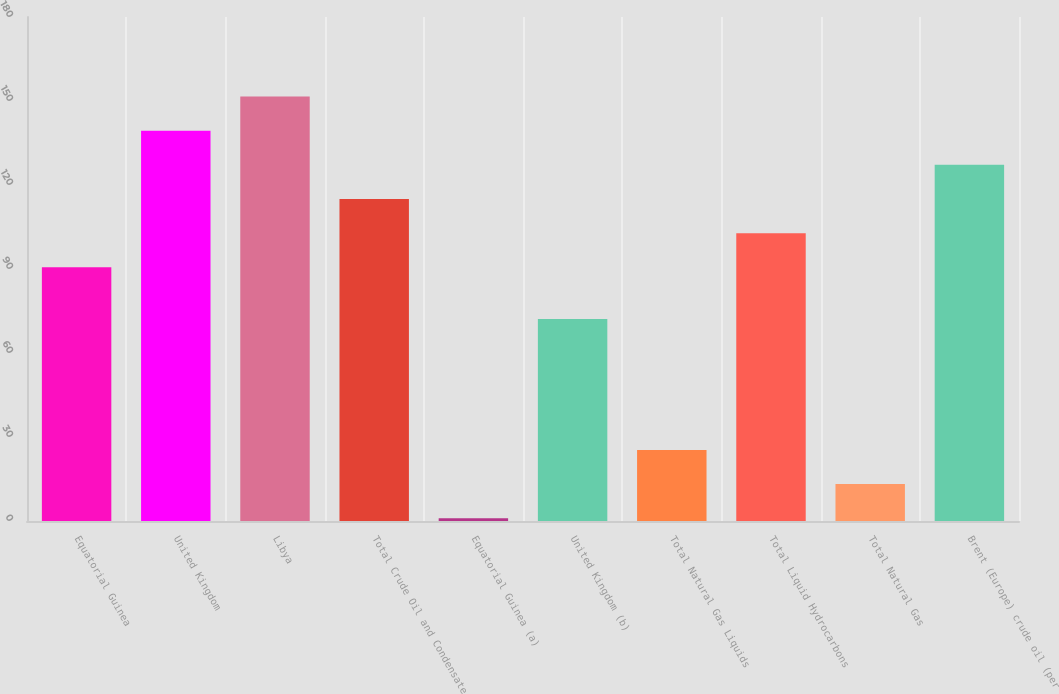<chart> <loc_0><loc_0><loc_500><loc_500><bar_chart><fcel>Equatorial Guinea<fcel>United Kingdom<fcel>Libya<fcel>Total Crude Oil and Condensate<fcel>Equatorial Guinea (a)<fcel>United Kingdom (b)<fcel>Total Natural Gas Liquids<fcel>Total Liquid Hydrocarbons<fcel>Total Natural Gas<fcel>Brent (Europe) crude oil (per<nl><fcel>90.62<fcel>139.38<fcel>151.57<fcel>115<fcel>1<fcel>72.14<fcel>25.38<fcel>102.81<fcel>13.19<fcel>127.19<nl></chart> 